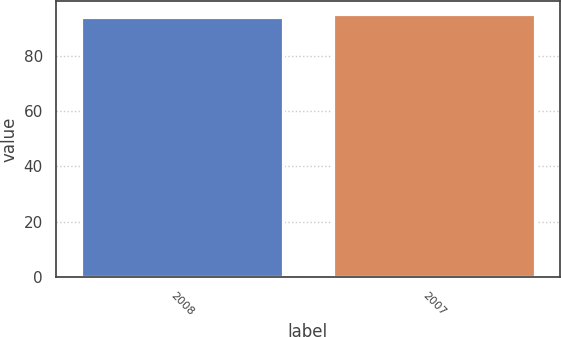Convert chart. <chart><loc_0><loc_0><loc_500><loc_500><bar_chart><fcel>2008<fcel>2007<nl><fcel>94<fcel>95<nl></chart> 